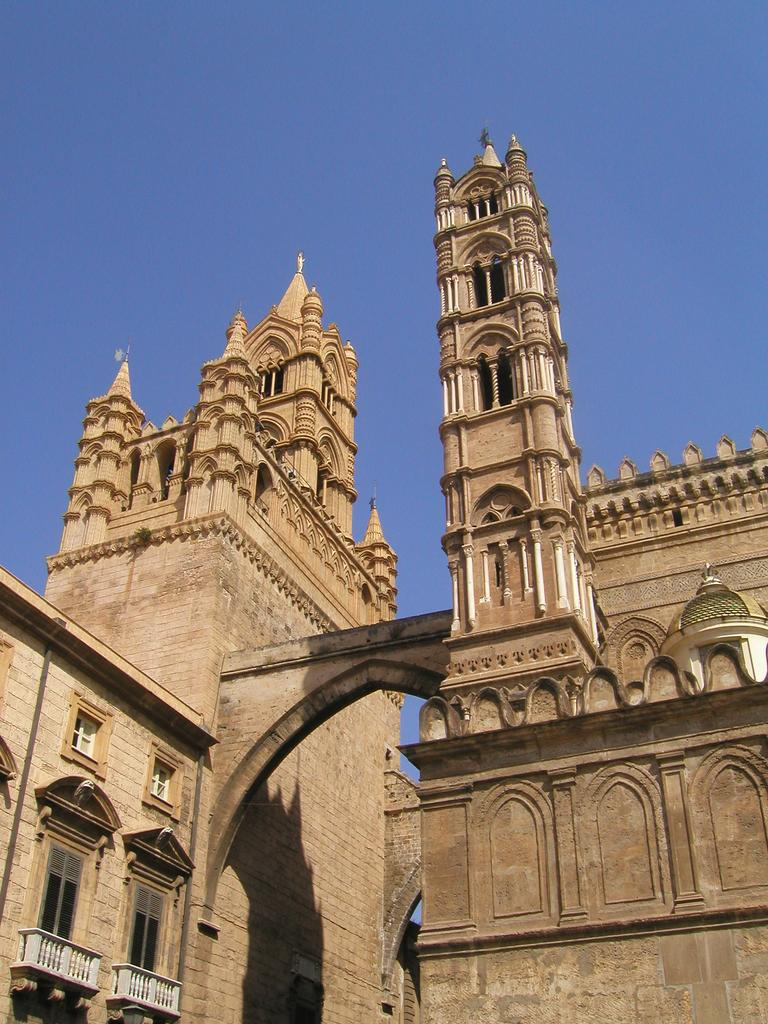What type of structure is present in the image? There is a building in the image. What feature can be seen on the building? The building has windows. What architectural element is visible in the image? There is an arch in the image. What is visible at the top of the image? The sky is visible at the top of the image. What type of powder is being used to clean the skin of the vegetable in the image? There is no powder, skin, or vegetable present in the image. 